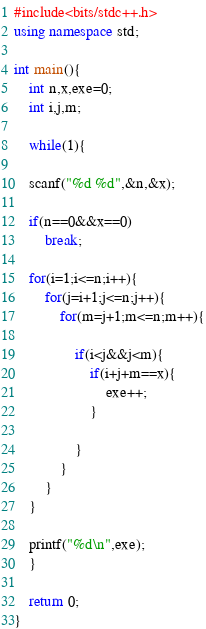<code> <loc_0><loc_0><loc_500><loc_500><_C++_>#include<bits/stdc++.h>
using namespace std;

int main(){
    int n,x,exe=0;
    int i,j,m;

    while(1){

    scanf("%d %d",&n,&x);

    if(n==0&&x==0)
        break;

    for(i=1;i<=n;i++){
        for(j=i+1;j<=n;j++){
            for(m=j+1;m<=n;m++){

                if(i<j&&j<m){
                    if(i+j+m==x){
                        exe++;
                    }

                }
            }
        }
    }

    printf("%d\n",exe);
    }

    return 0;
}


</code> 